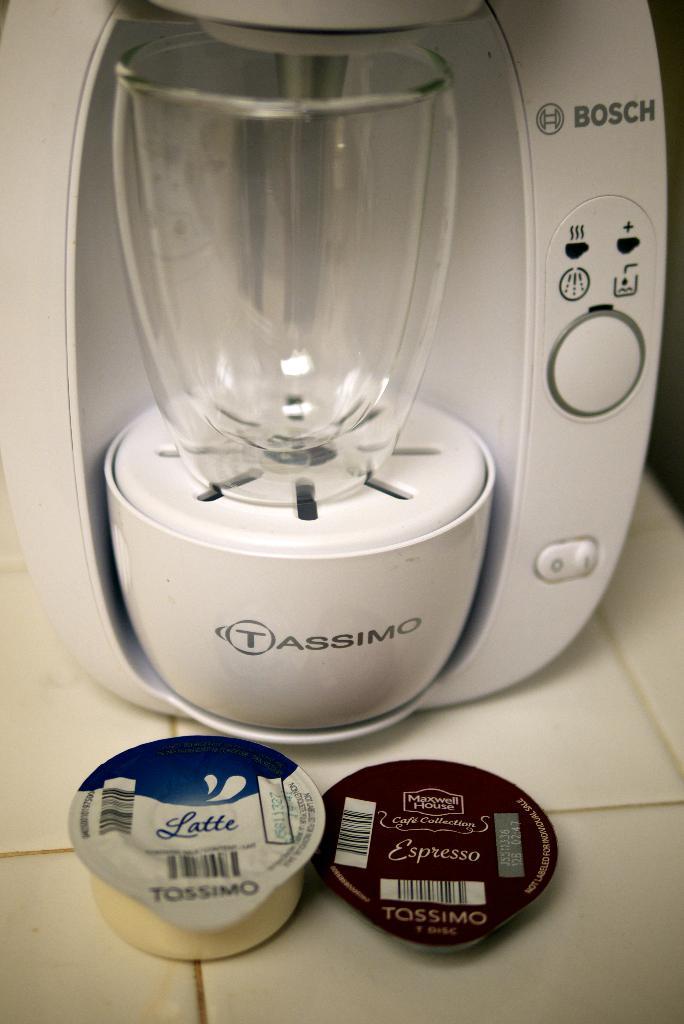What brand is this coffee maker?
Make the answer very short. Bosch. What beverage is in the pod on the left?
Provide a short and direct response. Latte. 